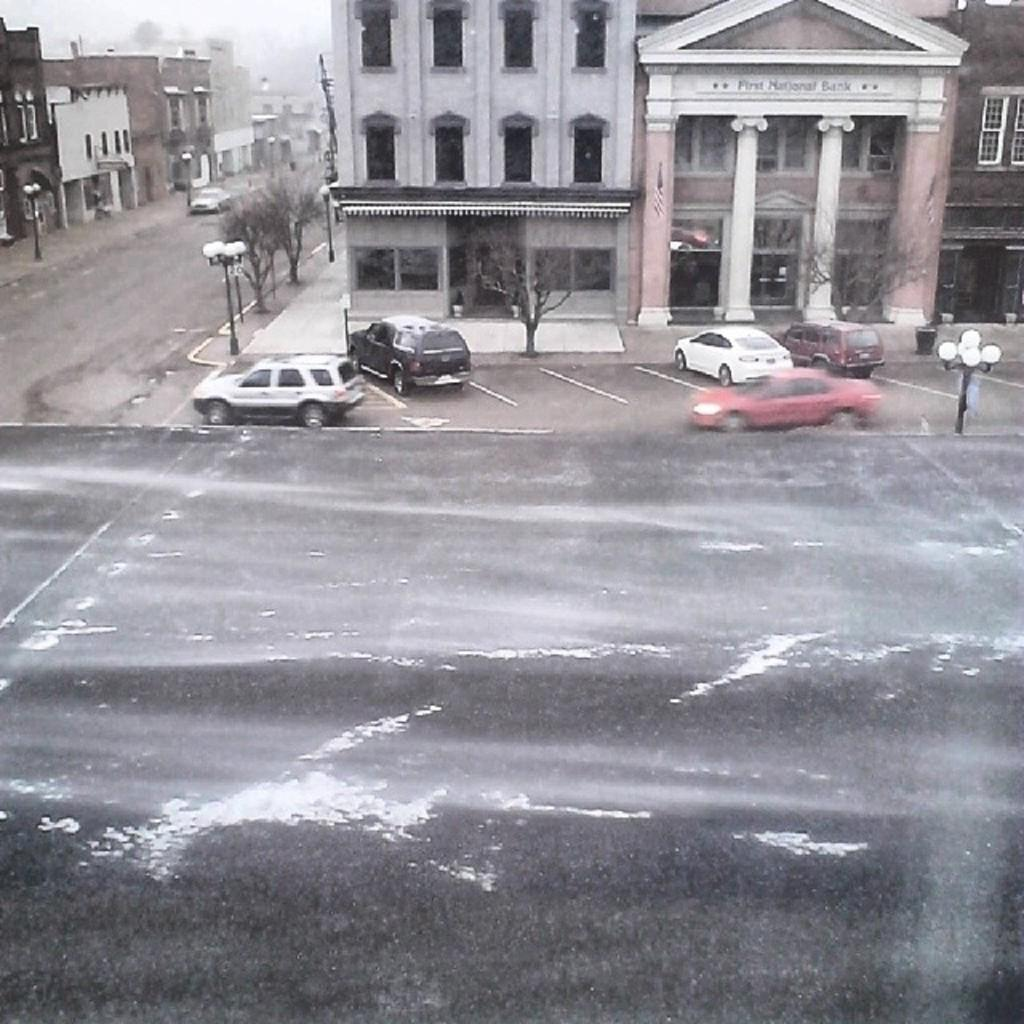What type of structures can be seen in the image? There are buildings in the image. What is located between the buildings? There is a road between the buildings. What type of vehicles are in front of the buildings? There are cars in front of the buildings. What type of vegetation is present in front of the buildings? Dry trees are present in front of the buildings. What type of lighting is visible in the image? Street lamps are visible in the image. What type of food is being served at the bushes in the image? There are no bushes or food present in the image. 